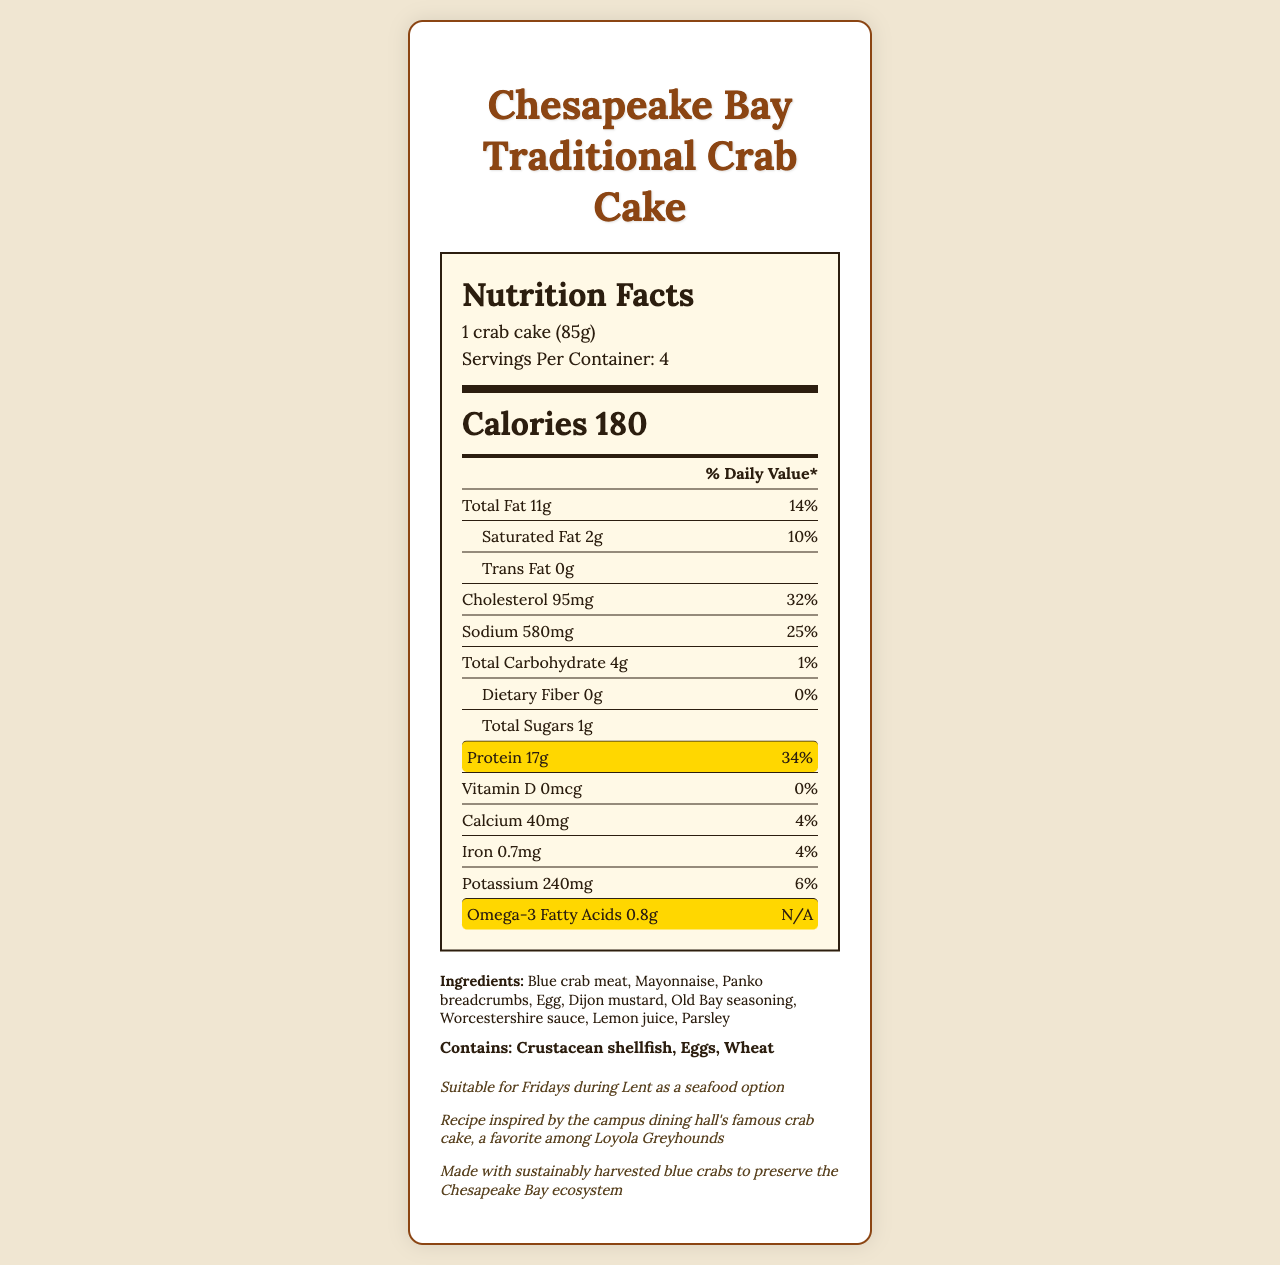what is the serving size? The serving size is explicitly stated in the document as "1 crab cake (85g)."
Answer: 1 crab cake (85g) how many servings are in this container? The document states that there are 4 servings per container.
Answer: 4 how many grams of protein are in one serving of the crab cake? The protein content per serving is given as 17g.
Answer: 17g what percentage of the daily value for protein does one serving provide? It is mentioned that one serving provides 34% of the daily value for protein.
Answer: 34% how much omega-3 fatty acids are in one serving? According to the document, one serving contains 0.8g of omega-3 fatty acids.
Answer: 0.8g how many calories are in one crab cake? The document states that there are 180 calories per serving.
Answer: 180 what is the amount of sodium in one serving? The amount of sodium per serving is listed as 580mg.
Answer: 580mg what is the daily value percentage of cholesterol found in one serving? The daily value for cholesterol per serving is given as 32%.
Answer: 32% which of the following ingredients is NOT in the crab cake? A. Blue crab meat B. Spinach C. Dijon mustard D. Lemon juice The list of ingredients does not include spinach, but it does include blue crab meat, Dijon mustard, and lemon juice.
Answer: B. Spinach which nutrient is highlighted in the document? A. Protein B. Carbohydrate C. Fiber D. Vitamin D Protein is highlighted in the document with a special background indicating its importance.
Answer: A. Protein is the crab cake suitable for Fridays during Lent as a seafood option? The document specifically mentions that the crab cake is suitable for Fridays during Lent as a seafood option.
Answer: Yes describe the main idea of this document The document is centered around the nutritional details of the crab cake, making note of its protein and omega-3 content, and providing additional context about its background and sustainability.
Answer: The document provides the nutrition facts for the Chesapeake Bay Traditional Crab Cake, including calories, fat, protein, omega-3 fatty acids, and other nutrients. It lists ingredients and allergens, and also mentions that the recipe is inspired by Loyola College in Maryland, ensuring it aligns with sustainability and Catholic dietary practices. where are the blue crabs sourced from? The document states that the blue crabs are sourced from the Chesapeake Bay.
Answer: Chesapeake Bay what is the amount of vitamin D in one serving? The document states that the amount of vitamin D per serving is 0mcg.
Answer: 0mcg what preparation method is suggested for the crab cakes? The preparation method provided in the document is broiled.
Answer: Broiled how much total carbohydrate is in one serving? The document states that there are 4g of total carbohydrates per serving.
Answer: 4g how many calories come from fat in this crab cake? The document does not provide information on how many calories come specifically from fat.
Answer: Not enough information how much saturated fat is in one serving relative to the daily value? The daily value percentage for saturated fat per serving is listed as 10%.
Answer: 10% how many contains allergens are in the crab cake? A. 2 B. 3 C. 4 D. 5 The document lists crustacean shellfish, eggs, and wheat as allergens contained in the crab cake.
Answer: B. 3 what is the daily value percentage of calcium provided by one serving? The document states that one serving provides 4% of the daily value for calcium.
Answer: 4% 